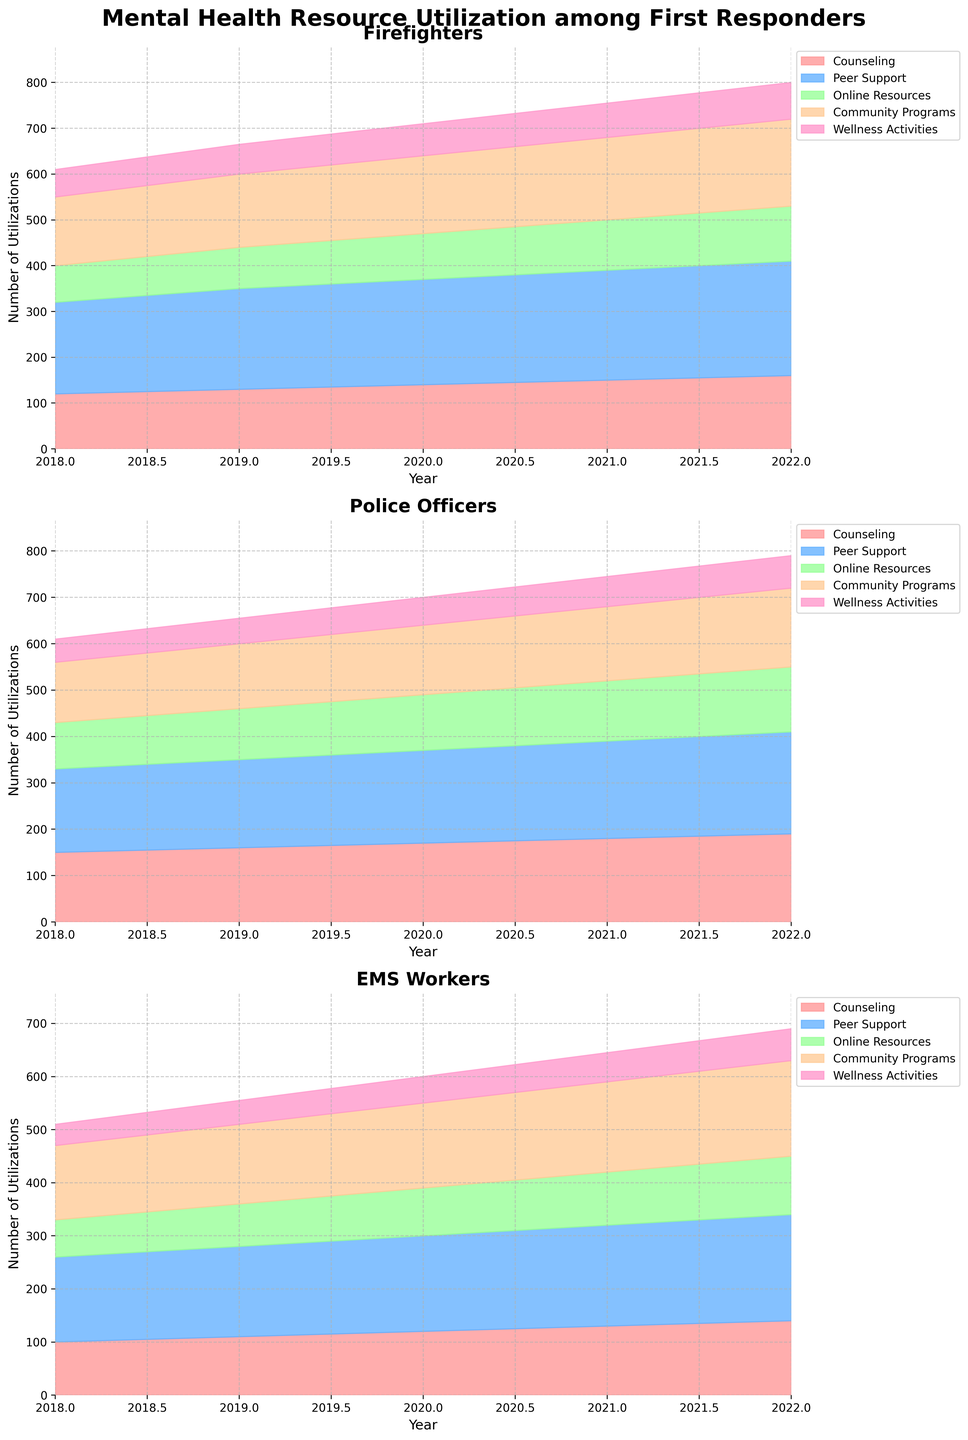How many types of mental health services are tracked for first responders? The figure shows mental health resources categorized into different services for first responders. By looking at the legend, we can see the different service types.
Answer: 5 Which type of service had the highest utilization for Police Officers in 2020? By looking at the 2020 subplot for Police Officers and observing the height of the areas stacked, it is clear that Peer Support has the highest value.
Answer: Peer Support What is the trend of Counseling service utilization for Firefighters from 2018 to 2022? By following the area for Counseling in the Firefighters subplot from 2018 to 2022, it shows a consistent increase over the years.
Answer: Increasing In which year did EMS Workers utilize Online Resources the most? By observing the EMS Workers subplot, the area representing Online Resources is the largest in 2022.
Answer: 2022 Compare the utilization of Wellness Activities between Firefighters and Police Officers in 2021. Which group had more utilization? By examining the two subplots for 2021, the area for Wellness Activities is higher in Firefighters compared to Police Officers.
Answer: Firefighters What's the total utilization of Peer Support for Firefighters over all the years? Sum the values of Peer Support for Firefighters from each year: 200 (2018) + 220 (2019) + 230 (2020) + 240 (2021) + 250 (2022) = 1140.
Answer: 1140 Which type of service showed the largest increase in utilization for EMS Workers from 2018 to 2022? By comparing the heights of different areas in the EMS Workers subplot from 2018 to 2022, Online Resources show the largest increase.
Answer: Online Resources How does the utilization of Community Programs for Firefighters in 2022 compare to that in 2018? By looking at the Community Programs areas in the Firefighters subplot for the years 2018 and 2022, the height is significantly higher in 2022.
Answer: Higher in 2022 What year marks the highest total utilization of services for Police Officers? Sum the areas for all services in the Police Officers subplot for each year; the largest total appears in 2022.
Answer: 2022 